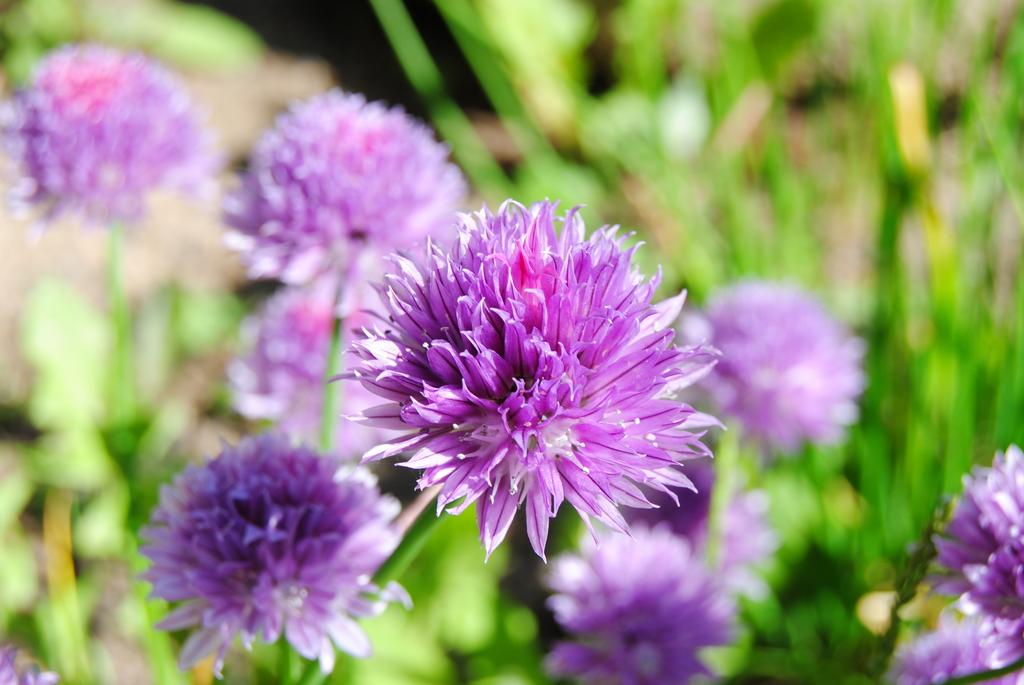What type of plant life is visible in the image? There are flowers and leaves in the image. Can you describe the flowers in the image? Unfortunately, the facts provided do not specify the type of flowers in the image. What is the context of the leaves in the image? The facts provided do not specify the context or location of the leaves in the image. What type of chess piece is depicted among the flowers in the image? There is no chess piece present in the image; it only features flowers and leaves. What type of dock can be seen in the background of the image? There is no dock present in the image; it only features flowers and leaves. 